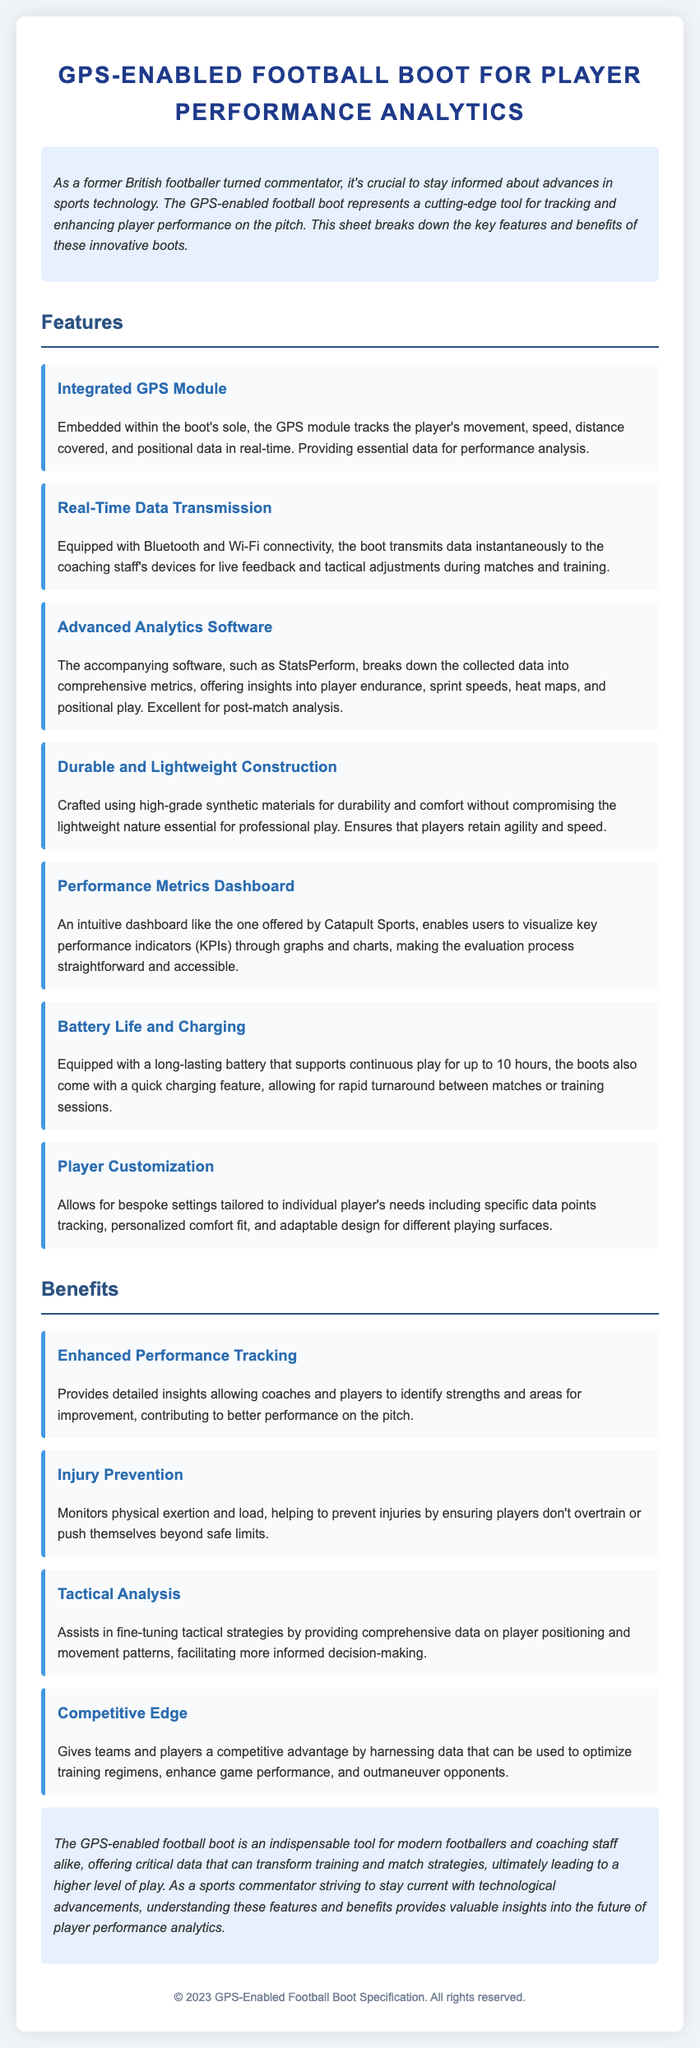What is the main technology used in the football boot? The main technology is an embedded GPS module that tracks the player's movement and data in real-time.
Answer: GPS module How long does the battery last during continuous play? The battery supports continuous play for up to 10 hours.
Answer: 10 hours What software is mentioned for analyzing performance data? The accompanying software mentioned is StatsPerform.
Answer: StatsPerform What benefit does the boot provide for injury prevention? The boot monitors physical exertion and load, helping to prevent injuries.
Answer: Injury prevention Which material is used to construct the boots for durability? The boots are crafted using high-grade synthetic materials.
Answer: Synthetic materials What type of connectivity does the boot have for data transmission? The boot is equipped with Bluetooth and Wi-Fi connectivity.
Answer: Bluetooth and Wi-Fi How does the performance metrics dashboard assist users? It enables users to visualize key performance indicators through graphs and charts.
Answer: Visualize KPIs What is a unique feature that allows player customization? The boots allow for bespoke settings tailored to individual player's needs.
Answer: Bespoke settings 